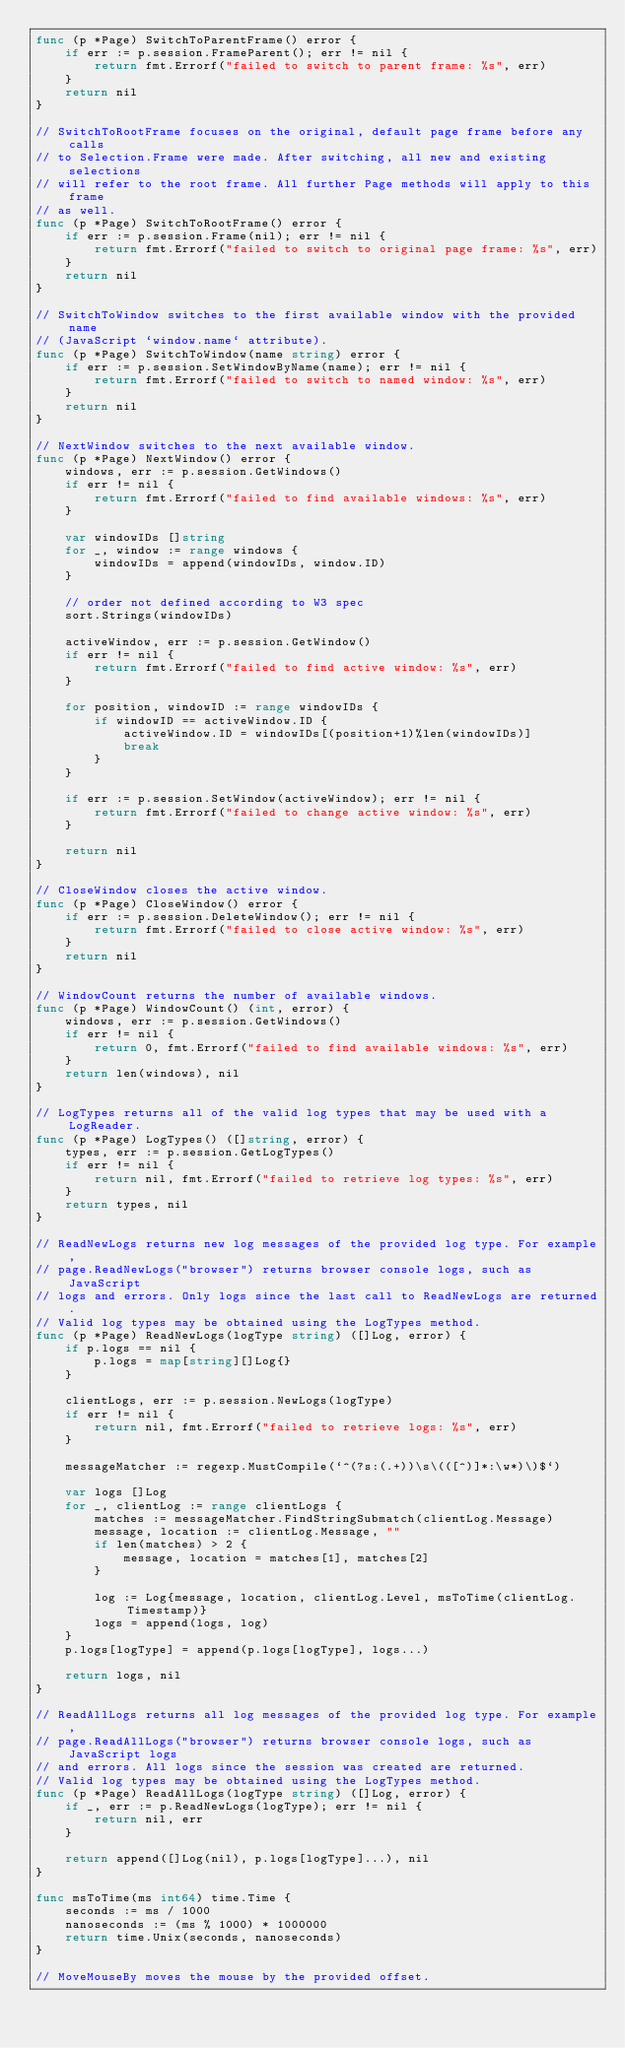Convert code to text. <code><loc_0><loc_0><loc_500><loc_500><_Go_>func (p *Page) SwitchToParentFrame() error {
	if err := p.session.FrameParent(); err != nil {
		return fmt.Errorf("failed to switch to parent frame: %s", err)
	}
	return nil
}

// SwitchToRootFrame focuses on the original, default page frame before any calls
// to Selection.Frame were made. After switching, all new and existing selections
// will refer to the root frame. All further Page methods will apply to this frame
// as well.
func (p *Page) SwitchToRootFrame() error {
	if err := p.session.Frame(nil); err != nil {
		return fmt.Errorf("failed to switch to original page frame: %s", err)
	}
	return nil
}

// SwitchToWindow switches to the first available window with the provided name
// (JavaScript `window.name` attribute).
func (p *Page) SwitchToWindow(name string) error {
	if err := p.session.SetWindowByName(name); err != nil {
		return fmt.Errorf("failed to switch to named window: %s", err)
	}
	return nil
}

// NextWindow switches to the next available window.
func (p *Page) NextWindow() error {
	windows, err := p.session.GetWindows()
	if err != nil {
		return fmt.Errorf("failed to find available windows: %s", err)
	}

	var windowIDs []string
	for _, window := range windows {
		windowIDs = append(windowIDs, window.ID)
	}

	// order not defined according to W3 spec
	sort.Strings(windowIDs)

	activeWindow, err := p.session.GetWindow()
	if err != nil {
		return fmt.Errorf("failed to find active window: %s", err)
	}

	for position, windowID := range windowIDs {
		if windowID == activeWindow.ID {
			activeWindow.ID = windowIDs[(position+1)%len(windowIDs)]
			break
		}
	}

	if err := p.session.SetWindow(activeWindow); err != nil {
		return fmt.Errorf("failed to change active window: %s", err)
	}

	return nil
}

// CloseWindow closes the active window.
func (p *Page) CloseWindow() error {
	if err := p.session.DeleteWindow(); err != nil {
		return fmt.Errorf("failed to close active window: %s", err)
	}
	return nil
}

// WindowCount returns the number of available windows.
func (p *Page) WindowCount() (int, error) {
	windows, err := p.session.GetWindows()
	if err != nil {
		return 0, fmt.Errorf("failed to find available windows: %s", err)
	}
	return len(windows), nil
}

// LogTypes returns all of the valid log types that may be used with a LogReader.
func (p *Page) LogTypes() ([]string, error) {
	types, err := p.session.GetLogTypes()
	if err != nil {
		return nil, fmt.Errorf("failed to retrieve log types: %s", err)
	}
	return types, nil
}

// ReadNewLogs returns new log messages of the provided log type. For example,
// page.ReadNewLogs("browser") returns browser console logs, such as JavaScript
// logs and errors. Only logs since the last call to ReadNewLogs are returned.
// Valid log types may be obtained using the LogTypes method.
func (p *Page) ReadNewLogs(logType string) ([]Log, error) {
	if p.logs == nil {
		p.logs = map[string][]Log{}
	}

	clientLogs, err := p.session.NewLogs(logType)
	if err != nil {
		return nil, fmt.Errorf("failed to retrieve logs: %s", err)
	}

	messageMatcher := regexp.MustCompile(`^(?s:(.+))\s\(([^)]*:\w*)\)$`)

	var logs []Log
	for _, clientLog := range clientLogs {
		matches := messageMatcher.FindStringSubmatch(clientLog.Message)
		message, location := clientLog.Message, ""
		if len(matches) > 2 {
			message, location = matches[1], matches[2]
		}

		log := Log{message, location, clientLog.Level, msToTime(clientLog.Timestamp)}
		logs = append(logs, log)
	}
	p.logs[logType] = append(p.logs[logType], logs...)

	return logs, nil
}

// ReadAllLogs returns all log messages of the provided log type. For example,
// page.ReadAllLogs("browser") returns browser console logs, such as JavaScript logs
// and errors. All logs since the session was created are returned.
// Valid log types may be obtained using the LogTypes method.
func (p *Page) ReadAllLogs(logType string) ([]Log, error) {
	if _, err := p.ReadNewLogs(logType); err != nil {
		return nil, err
	}

	return append([]Log(nil), p.logs[logType]...), nil
}

func msToTime(ms int64) time.Time {
	seconds := ms / 1000
	nanoseconds := (ms % 1000) * 1000000
	return time.Unix(seconds, nanoseconds)
}

// MoveMouseBy moves the mouse by the provided offset.</code> 